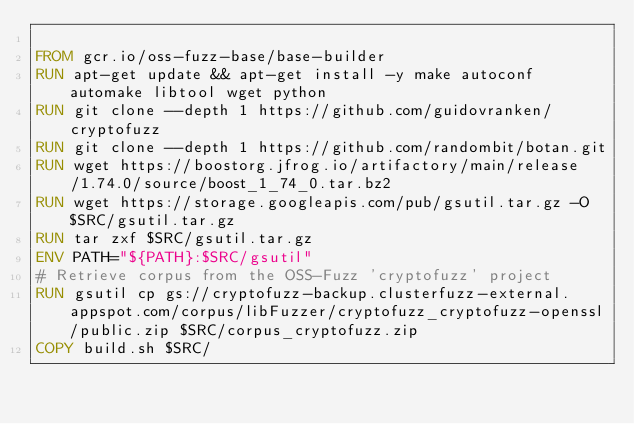<code> <loc_0><loc_0><loc_500><loc_500><_Dockerfile_>
FROM gcr.io/oss-fuzz-base/base-builder
RUN apt-get update && apt-get install -y make autoconf automake libtool wget python
RUN git clone --depth 1 https://github.com/guidovranken/cryptofuzz
RUN git clone --depth 1 https://github.com/randombit/botan.git
RUN wget https://boostorg.jfrog.io/artifactory/main/release/1.74.0/source/boost_1_74_0.tar.bz2
RUN wget https://storage.googleapis.com/pub/gsutil.tar.gz -O $SRC/gsutil.tar.gz
RUN tar zxf $SRC/gsutil.tar.gz
ENV PATH="${PATH}:$SRC/gsutil"
# Retrieve corpus from the OSS-Fuzz 'cryptofuzz' project
RUN gsutil cp gs://cryptofuzz-backup.clusterfuzz-external.appspot.com/corpus/libFuzzer/cryptofuzz_cryptofuzz-openssl/public.zip $SRC/corpus_cryptofuzz.zip
COPY build.sh $SRC/
</code> 